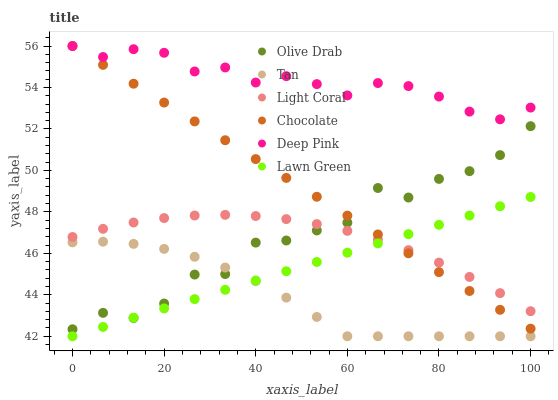Does Tan have the minimum area under the curve?
Answer yes or no. Yes. Does Deep Pink have the maximum area under the curve?
Answer yes or no. Yes. Does Chocolate have the minimum area under the curve?
Answer yes or no. No. Does Chocolate have the maximum area under the curve?
Answer yes or no. No. Is Lawn Green the smoothest?
Answer yes or no. Yes. Is Olive Drab the roughest?
Answer yes or no. Yes. Is Deep Pink the smoothest?
Answer yes or no. No. Is Deep Pink the roughest?
Answer yes or no. No. Does Lawn Green have the lowest value?
Answer yes or no. Yes. Does Chocolate have the lowest value?
Answer yes or no. No. Does Chocolate have the highest value?
Answer yes or no. Yes. Does Light Coral have the highest value?
Answer yes or no. No. Is Tan less than Chocolate?
Answer yes or no. Yes. Is Chocolate greater than Tan?
Answer yes or no. Yes. Does Chocolate intersect Deep Pink?
Answer yes or no. Yes. Is Chocolate less than Deep Pink?
Answer yes or no. No. Is Chocolate greater than Deep Pink?
Answer yes or no. No. Does Tan intersect Chocolate?
Answer yes or no. No. 